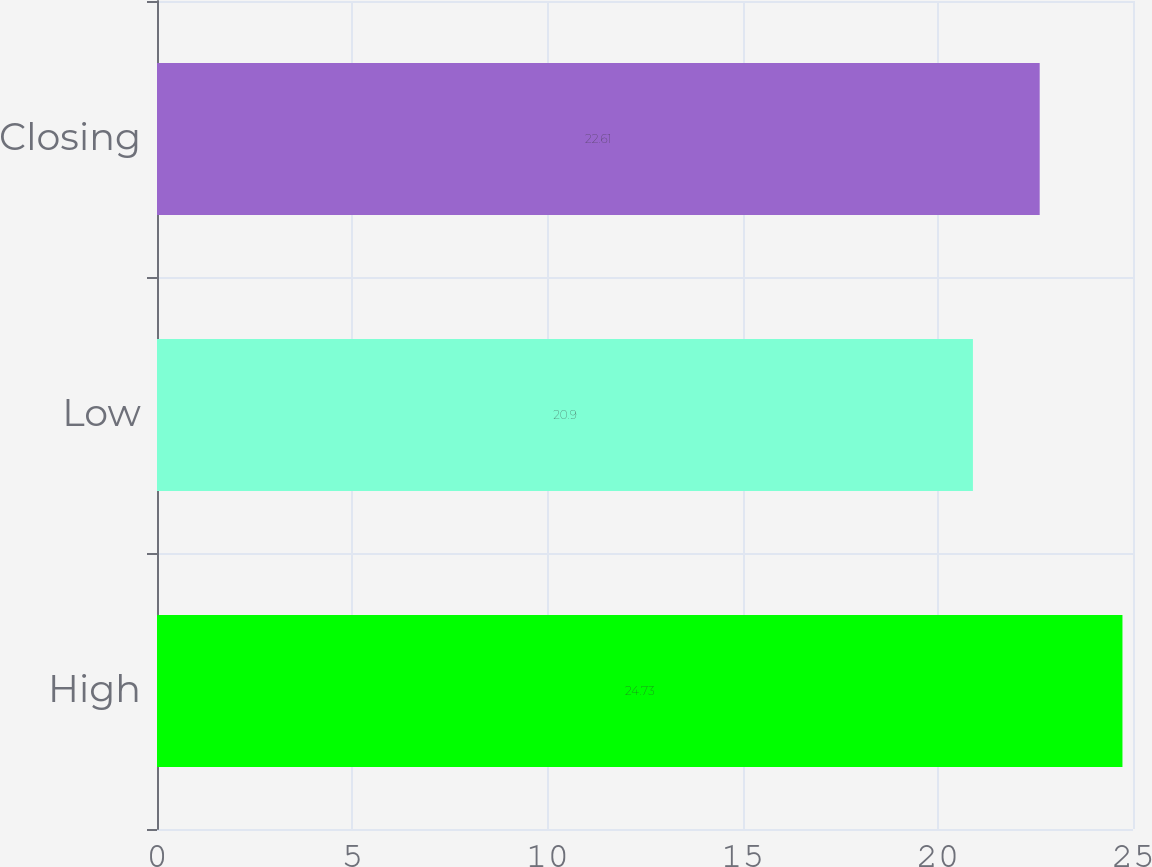<chart> <loc_0><loc_0><loc_500><loc_500><bar_chart><fcel>High<fcel>Low<fcel>Closing<nl><fcel>24.73<fcel>20.9<fcel>22.61<nl></chart> 